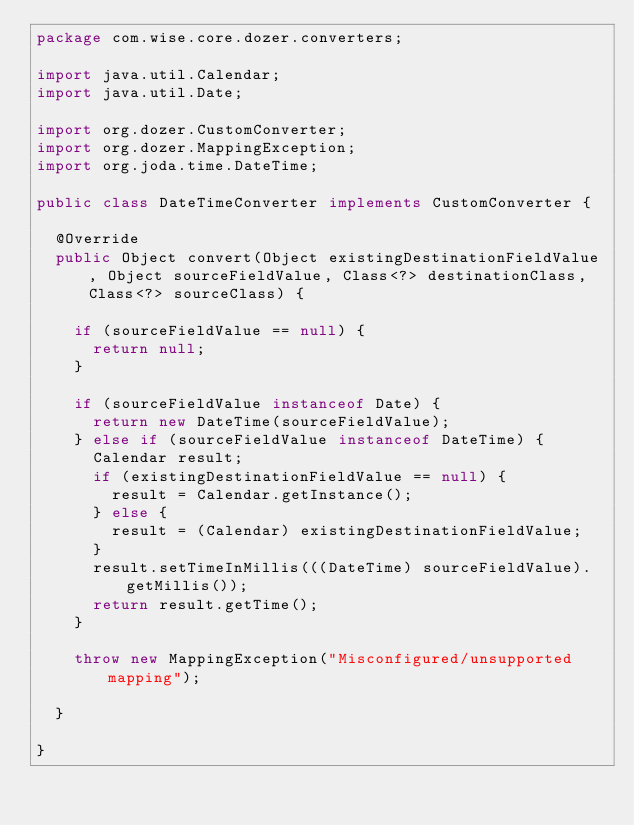<code> <loc_0><loc_0><loc_500><loc_500><_Java_>package com.wise.core.dozer.converters;

import java.util.Calendar;
import java.util.Date;

import org.dozer.CustomConverter;
import org.dozer.MappingException;
import org.joda.time.DateTime;

public class DateTimeConverter implements CustomConverter {

	@Override
	public Object convert(Object existingDestinationFieldValue, Object sourceFieldValue, Class<?> destinationClass, Class<?> sourceClass) {
		
		if (sourceFieldValue == null) {
			return null;
		}
		
		if (sourceFieldValue instanceof Date) {
			return new DateTime(sourceFieldValue);
		} else if (sourceFieldValue instanceof DateTime) {
			Calendar result;
			if (existingDestinationFieldValue == null) {
				result = Calendar.getInstance();
			} else {
				result = (Calendar) existingDestinationFieldValue;
			}
			result.setTimeInMillis(((DateTime) sourceFieldValue).getMillis());
			return result.getTime();
		}
		
		throw new MappingException("Misconfigured/unsupported mapping");
		
	}

}
</code> 